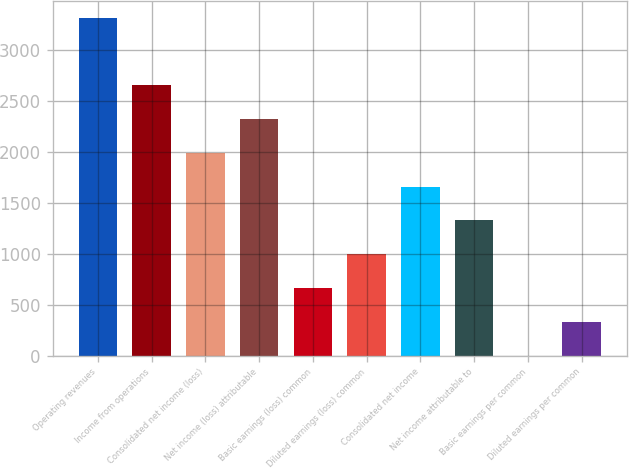Convert chart to OTSL. <chart><loc_0><loc_0><loc_500><loc_500><bar_chart><fcel>Operating revenues<fcel>Income from operations<fcel>Consolidated net income (loss)<fcel>Net income (loss) attributable<fcel>Basic earnings (loss) common<fcel>Diluted earnings (loss) common<fcel>Consolidated net income<fcel>Net income attributable to<fcel>Basic earnings per common<fcel>Diluted earnings per common<nl><fcel>3315<fcel>2652.11<fcel>1989.2<fcel>2320.66<fcel>663.37<fcel>994.83<fcel>1657.74<fcel>1326.29<fcel>0.45<fcel>331.91<nl></chart> 